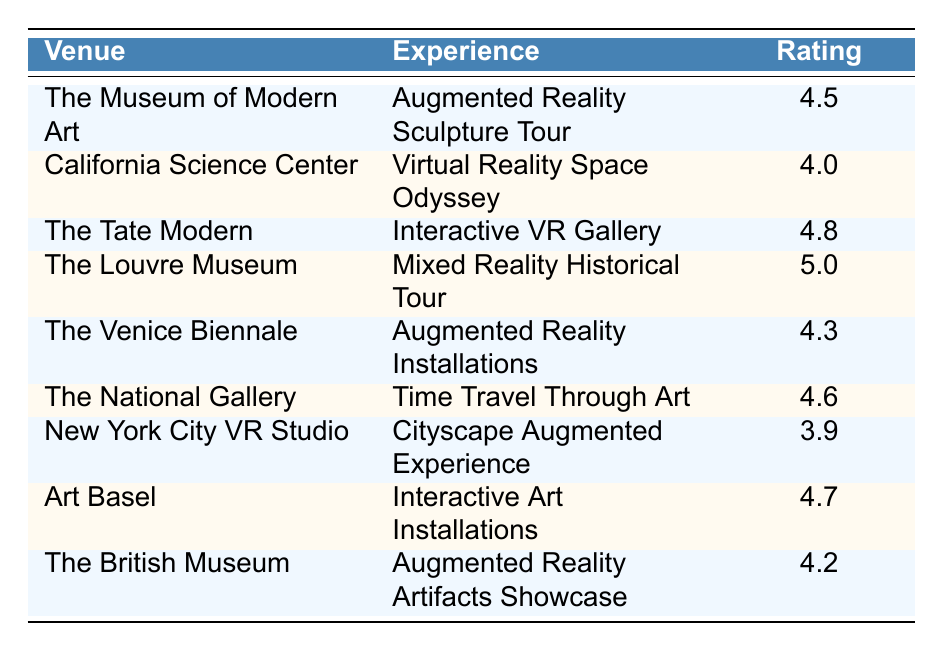What is the highest rating among the mixed reality experiences? The highest rating listed in the table is 5.0, which corresponds to the "Mixed Reality Historical Tour" at The Louvre Museum.
Answer: 5.0 Which venue has the lowest rating? The venue with the lowest rating is the "New York City VR Studio", which has a rating of 3.9.
Answer: New York City VR Studio What is the average rating of all mixed reality experiences? The ratings are 4.5, 4.0, 4.8, 5.0, 4.3, 4.6, 3.9, 4.7, 4.2. The sum of these ratings is 37.0. There are 9 ratings, so the average is 37.0 / 9 ≈ 4.11.
Answer: Approximately 4.11 Did any venue receive a rating of 4.6 or higher? Yes, there are several venues that received a rating of 4.6 or higher: The Tate Modern (4.8), The Louvre Museum (5.0), The National Gallery (4.6), Art Basel (4.7).
Answer: Yes Which experience had the best visitor feedback comments based on the rating? The experience with the highest rating of 5.0, "Mixed Reality Historical Tour" at The Louvre Museum, received the best feedback comments, describing it as brilliantly integrated and immersive.
Answer: Mixed Reality Historical Tour at The Louvre Museum Is there a significant difference between the highest and lowest ratings? The highest rating is 5.0 and the lowest rating is 3.9; thus, the difference is 5.0 - 3.9 = 1.1, which indicates a significant difference in visitor feedback.
Answer: Yes How many experiences received ratings above 4.5? The experiences that received ratings above 4.5 are: The Tate Modern (4.8), The Louvre Museum (5.0), The National Gallery (4.6), and Art Basel (4.7). In total, this makes 4 experiences.
Answer: 4 What percentage of the experiences are rated below 4.0? There is only one experience rated below 4.0, which is "Cityscape Augmented Experience" at the New York City VR Studio. Since there are 9 experiences total, the percentage is (1 / 9) * 100 ≈ 11.11%.
Answer: Approximately 11.11% Which venue had the most diverse feedback comments based on the given data? While "Mixed Reality Historical Tour" received two positive and immersive comments, "Augmented Reality Installations" at The Venice Biennale presented contrasting opinions; it had a fresh perspective but mentioned some installations that didn't work well. This shows a diverse range of feedback.
Answer: Augmented Reality Installations at The Venice Biennale What specific feedback did visitors provide for the experience rated 4.2? The experience rated 4.2 is "Augmented Reality Artifacts Showcase" at The British Museum. Visitors commented that it was educational and entertaining, but mentioned some glitches with the AR elements.
Answer: Educational and entertaining, but glitchy 